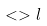<formula> <loc_0><loc_0><loc_500><loc_500>< > l</formula> 